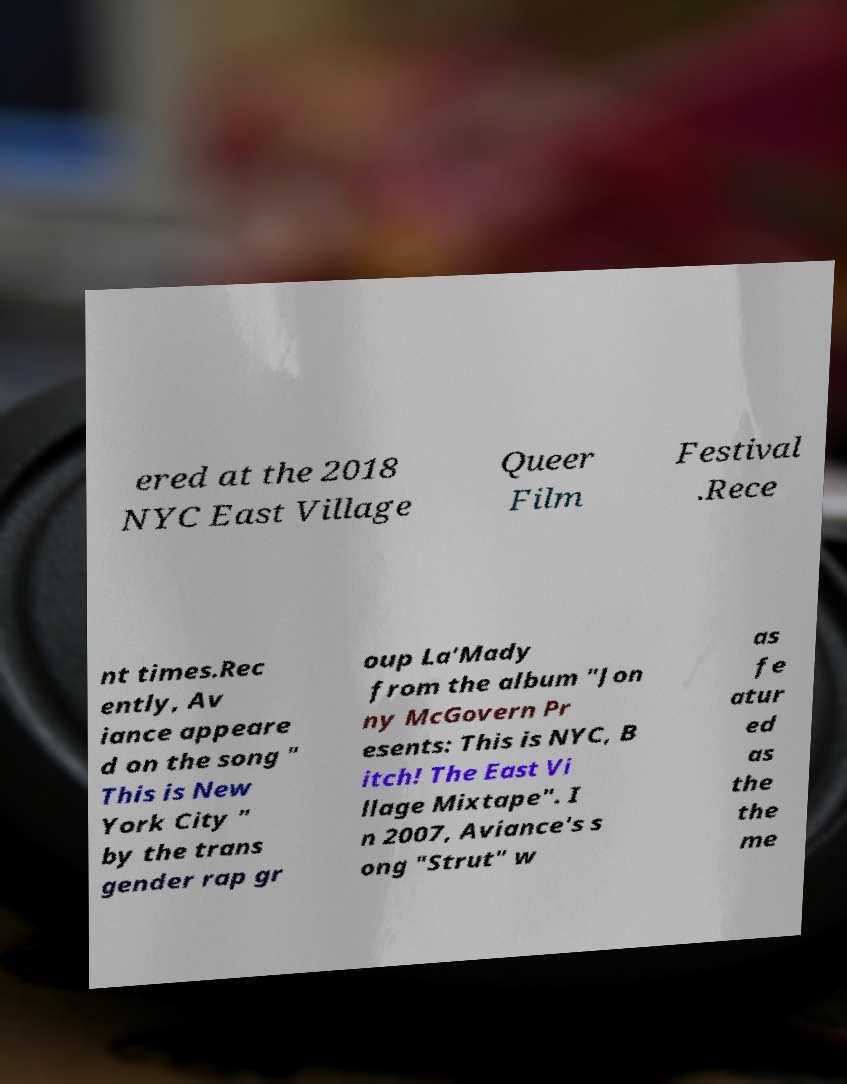I need the written content from this picture converted into text. Can you do that? ered at the 2018 NYC East Village Queer Film Festival .Rece nt times.Rec ently, Av iance appeare d on the song " This is New York City " by the trans gender rap gr oup La'Mady from the album "Jon ny McGovern Pr esents: This is NYC, B itch! The East Vi llage Mixtape". I n 2007, Aviance's s ong "Strut" w as fe atur ed as the the me 